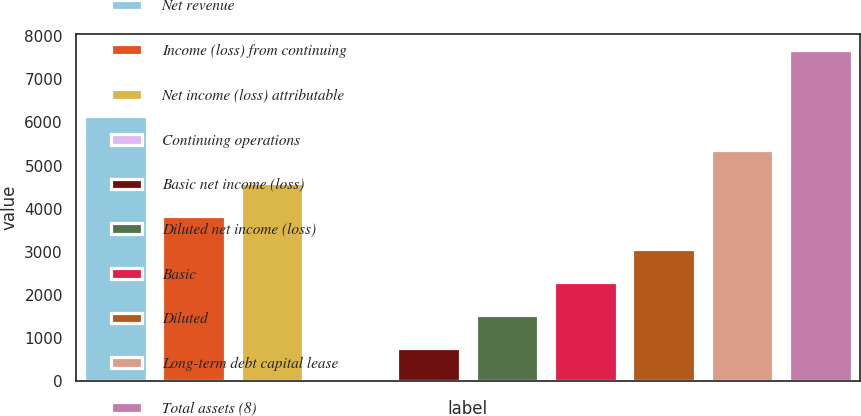<chart> <loc_0><loc_0><loc_500><loc_500><bar_chart><fcel>Net revenue<fcel>Income (loss) from continuing<fcel>Net income (loss) attributable<fcel>Continuing operations<fcel>Basic net income (loss)<fcel>Diluted net income (loss)<fcel>Basic<fcel>Diluted<fcel>Long-term debt capital lease<fcel>Total assets (8)<nl><fcel>6138.43<fcel>3838.03<fcel>4604.83<fcel>4.03<fcel>770.83<fcel>1537.63<fcel>2304.43<fcel>3071.23<fcel>5371.63<fcel>7672<nl></chart> 